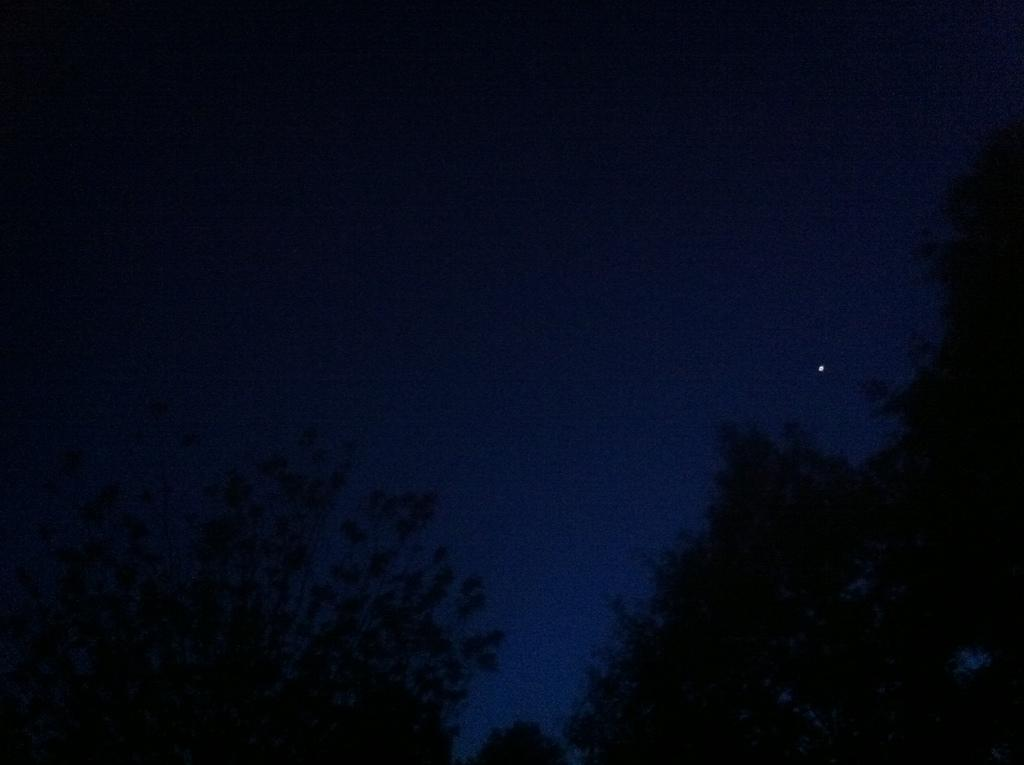What type of vegetation can be seen in the image? There are trees in the image. What celestial object is visible in the sky? There is a star visible in the sky. What type of stocking is hanging from the tree in the image? There is no stocking hanging from the tree in the image; only trees and a star are present. What kind of bun can be seen in the image? There is no bun present in the image. 